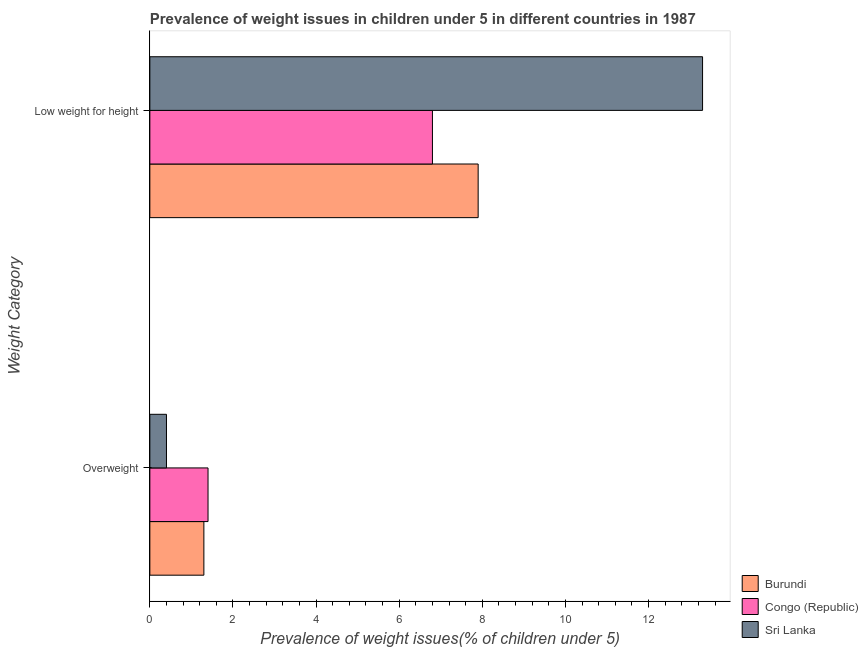How many different coloured bars are there?
Provide a short and direct response. 3. How many groups of bars are there?
Your response must be concise. 2. How many bars are there on the 2nd tick from the top?
Your answer should be compact. 3. What is the label of the 2nd group of bars from the top?
Keep it short and to the point. Overweight. What is the percentage of overweight children in Sri Lanka?
Offer a terse response. 0.4. Across all countries, what is the maximum percentage of underweight children?
Your answer should be compact. 13.3. Across all countries, what is the minimum percentage of overweight children?
Your answer should be compact. 0.4. In which country was the percentage of overweight children maximum?
Keep it short and to the point. Congo (Republic). In which country was the percentage of underweight children minimum?
Provide a succinct answer. Congo (Republic). What is the total percentage of overweight children in the graph?
Ensure brevity in your answer.  3.1. What is the difference between the percentage of underweight children in Burundi and that in Congo (Republic)?
Your answer should be compact. 1.1. What is the difference between the percentage of underweight children in Burundi and the percentage of overweight children in Congo (Republic)?
Your response must be concise. 6.5. What is the average percentage of overweight children per country?
Your answer should be compact. 1.03. What is the difference between the percentage of overweight children and percentage of underweight children in Burundi?
Keep it short and to the point. -6.6. What is the ratio of the percentage of overweight children in Burundi to that in Congo (Republic)?
Your answer should be very brief. 0.93. What does the 1st bar from the top in Low weight for height represents?
Your answer should be compact. Sri Lanka. What does the 3rd bar from the bottom in Overweight represents?
Offer a very short reply. Sri Lanka. How many bars are there?
Your answer should be very brief. 6. Are all the bars in the graph horizontal?
Offer a very short reply. Yes. How many countries are there in the graph?
Your response must be concise. 3. Are the values on the major ticks of X-axis written in scientific E-notation?
Offer a terse response. No. Does the graph contain any zero values?
Provide a short and direct response. No. Where does the legend appear in the graph?
Keep it short and to the point. Bottom right. How many legend labels are there?
Your answer should be compact. 3. How are the legend labels stacked?
Offer a terse response. Vertical. What is the title of the graph?
Keep it short and to the point. Prevalence of weight issues in children under 5 in different countries in 1987. What is the label or title of the X-axis?
Provide a short and direct response. Prevalence of weight issues(% of children under 5). What is the label or title of the Y-axis?
Offer a very short reply. Weight Category. What is the Prevalence of weight issues(% of children under 5) of Burundi in Overweight?
Keep it short and to the point. 1.3. What is the Prevalence of weight issues(% of children under 5) in Congo (Republic) in Overweight?
Provide a succinct answer. 1.4. What is the Prevalence of weight issues(% of children under 5) of Sri Lanka in Overweight?
Your answer should be very brief. 0.4. What is the Prevalence of weight issues(% of children under 5) in Burundi in Low weight for height?
Your answer should be compact. 7.9. What is the Prevalence of weight issues(% of children under 5) of Congo (Republic) in Low weight for height?
Provide a succinct answer. 6.8. What is the Prevalence of weight issues(% of children under 5) of Sri Lanka in Low weight for height?
Your answer should be compact. 13.3. Across all Weight Category, what is the maximum Prevalence of weight issues(% of children under 5) in Burundi?
Your response must be concise. 7.9. Across all Weight Category, what is the maximum Prevalence of weight issues(% of children under 5) of Congo (Republic)?
Ensure brevity in your answer.  6.8. Across all Weight Category, what is the maximum Prevalence of weight issues(% of children under 5) of Sri Lanka?
Provide a short and direct response. 13.3. Across all Weight Category, what is the minimum Prevalence of weight issues(% of children under 5) in Burundi?
Your answer should be very brief. 1.3. Across all Weight Category, what is the minimum Prevalence of weight issues(% of children under 5) in Congo (Republic)?
Provide a short and direct response. 1.4. Across all Weight Category, what is the minimum Prevalence of weight issues(% of children under 5) of Sri Lanka?
Your answer should be very brief. 0.4. What is the total Prevalence of weight issues(% of children under 5) of Sri Lanka in the graph?
Your answer should be very brief. 13.7. What is the difference between the Prevalence of weight issues(% of children under 5) of Burundi in Overweight and that in Low weight for height?
Ensure brevity in your answer.  -6.6. What is the difference between the Prevalence of weight issues(% of children under 5) in Congo (Republic) in Overweight and that in Low weight for height?
Offer a very short reply. -5.4. What is the difference between the Prevalence of weight issues(% of children under 5) in Sri Lanka in Overweight and that in Low weight for height?
Give a very brief answer. -12.9. What is the difference between the Prevalence of weight issues(% of children under 5) of Burundi in Overweight and the Prevalence of weight issues(% of children under 5) of Congo (Republic) in Low weight for height?
Your answer should be very brief. -5.5. What is the difference between the Prevalence of weight issues(% of children under 5) in Congo (Republic) in Overweight and the Prevalence of weight issues(% of children under 5) in Sri Lanka in Low weight for height?
Provide a succinct answer. -11.9. What is the average Prevalence of weight issues(% of children under 5) in Burundi per Weight Category?
Your response must be concise. 4.6. What is the average Prevalence of weight issues(% of children under 5) in Congo (Republic) per Weight Category?
Offer a very short reply. 4.1. What is the average Prevalence of weight issues(% of children under 5) of Sri Lanka per Weight Category?
Give a very brief answer. 6.85. What is the difference between the Prevalence of weight issues(% of children under 5) of Congo (Republic) and Prevalence of weight issues(% of children under 5) of Sri Lanka in Overweight?
Offer a very short reply. 1. What is the difference between the Prevalence of weight issues(% of children under 5) of Burundi and Prevalence of weight issues(% of children under 5) of Congo (Republic) in Low weight for height?
Your response must be concise. 1.1. What is the difference between the Prevalence of weight issues(% of children under 5) in Congo (Republic) and Prevalence of weight issues(% of children under 5) in Sri Lanka in Low weight for height?
Ensure brevity in your answer.  -6.5. What is the ratio of the Prevalence of weight issues(% of children under 5) in Burundi in Overweight to that in Low weight for height?
Offer a terse response. 0.16. What is the ratio of the Prevalence of weight issues(% of children under 5) of Congo (Republic) in Overweight to that in Low weight for height?
Your answer should be compact. 0.21. What is the ratio of the Prevalence of weight issues(% of children under 5) of Sri Lanka in Overweight to that in Low weight for height?
Keep it short and to the point. 0.03. What is the difference between the highest and the second highest Prevalence of weight issues(% of children under 5) of Burundi?
Provide a short and direct response. 6.6. What is the difference between the highest and the lowest Prevalence of weight issues(% of children under 5) of Congo (Republic)?
Your answer should be very brief. 5.4. What is the difference between the highest and the lowest Prevalence of weight issues(% of children under 5) of Sri Lanka?
Your response must be concise. 12.9. 